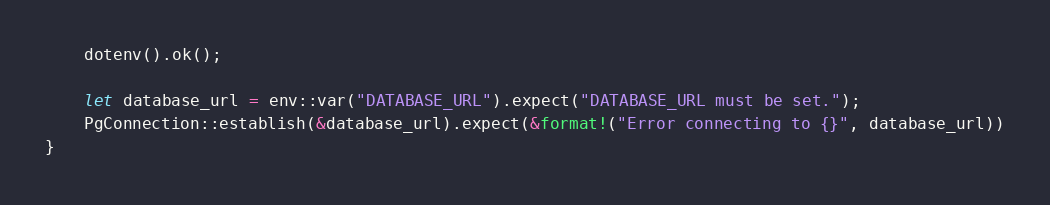Convert code to text. <code><loc_0><loc_0><loc_500><loc_500><_Rust_>    dotenv().ok();

    let database_url = env::var("DATABASE_URL").expect("DATABASE_URL must be set.");
    PgConnection::establish(&database_url).expect(&format!("Error connecting to {}", database_url))
}
</code> 